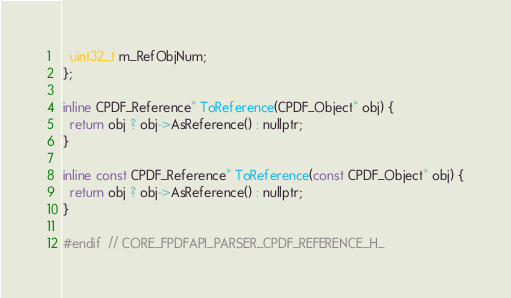Convert code to text. <code><loc_0><loc_0><loc_500><loc_500><_C_>  uint32_t m_RefObjNum;
};

inline CPDF_Reference* ToReference(CPDF_Object* obj) {
  return obj ? obj->AsReference() : nullptr;
}

inline const CPDF_Reference* ToReference(const CPDF_Object* obj) {
  return obj ? obj->AsReference() : nullptr;
}

#endif  // CORE_FPDFAPI_PARSER_CPDF_REFERENCE_H_
</code> 